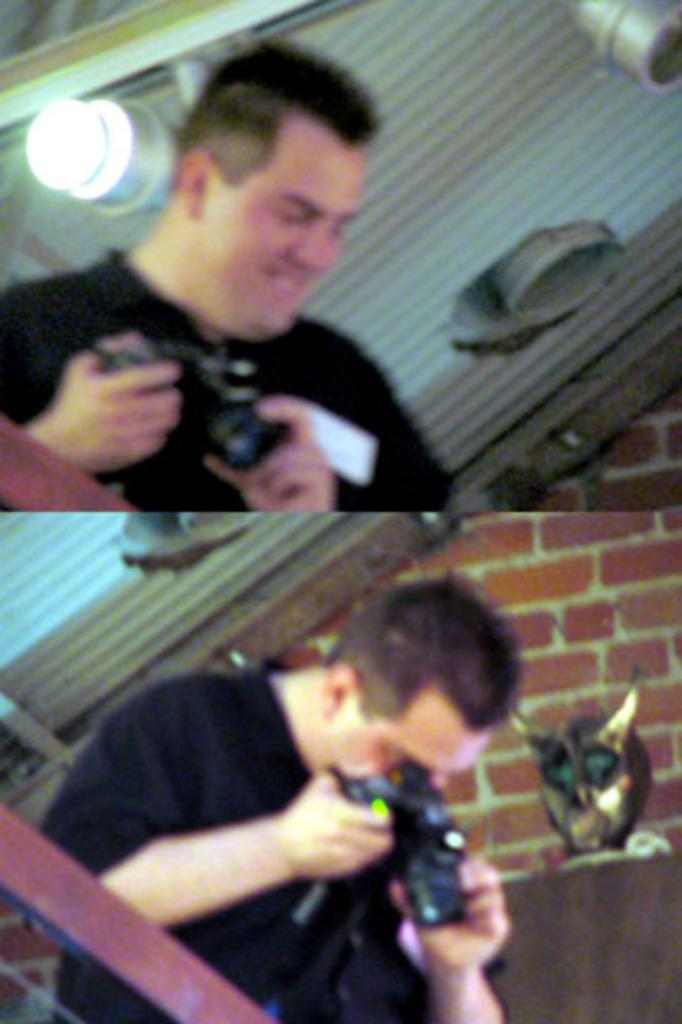What can be seen in the image? There are men in the image. What are the men holding in their hands? The men are holding cameras in their hands. How many ladybugs can be seen on the men's faces in the image? There are no ladybugs present in the image, and therefore none can be seen on the men's faces. 